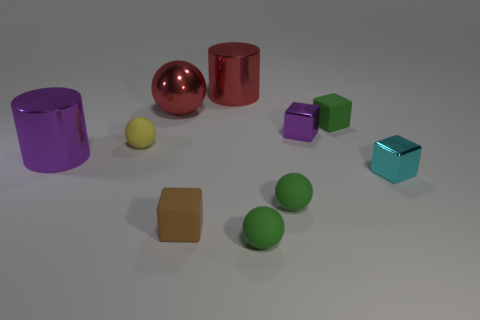Subtract all cylinders. How many objects are left? 8 Subtract all purple shiny cubes. Subtract all purple metallic cubes. How many objects are left? 8 Add 2 matte balls. How many matte balls are left? 5 Add 1 red balls. How many red balls exist? 2 Subtract 1 cyan blocks. How many objects are left? 9 